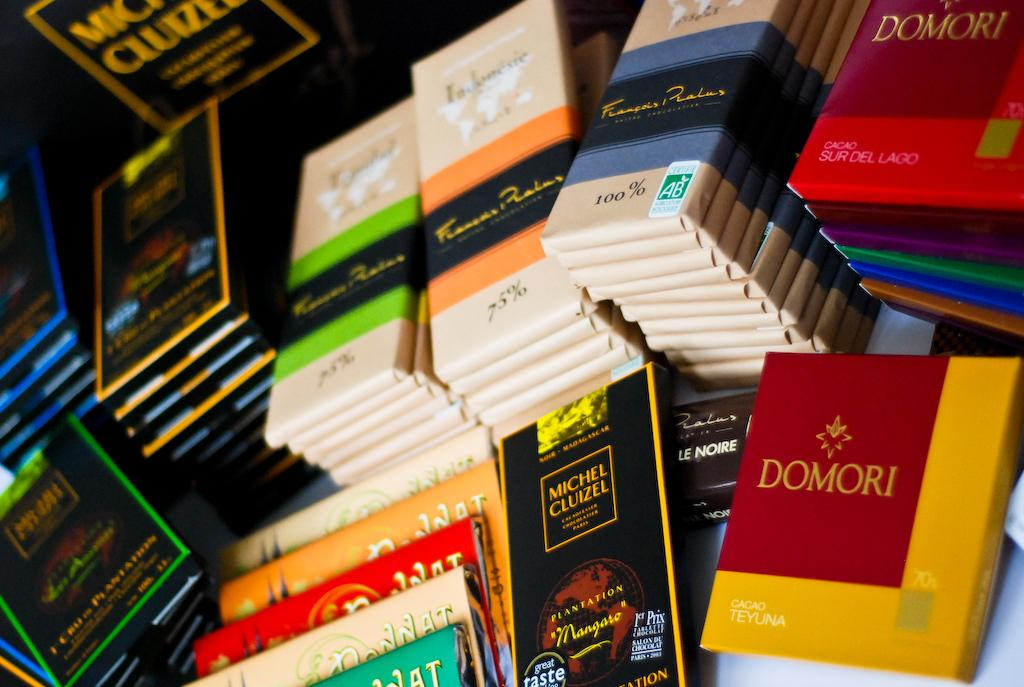Provide a one-sentence caption for the provided image. Bars of chocolate sit stacked next to each other with one in red and yellow that says Domori. 